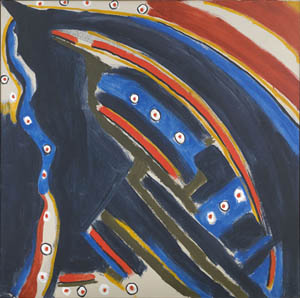Can you create a fictional story inspired by this image? In a far-off realm beyond the limits of space and time, there existed a cosmic entity known as the Astral Voyager. The Voyager was created from the very fabric of the universe, a swirling amalgam of deep blue voids and shimmering cosmic energy outlined by celestial forces. Each dot of red, yellow, and white represented a living star, housing entire worlds teeming with life and stories untold.

One day, the stars began to vanish one by one, consumed by an unknown darkness creeping through the universe. The Astral Voyager embarked on a journey across the cosmos, driven by an insatiable desire to uncover the mystery and restore light to the stars. Along its path, the Voyager encountered numerous galaxies and constellations, gathering knowledge and allies.

In a climactic battle, the Voyager confronted the source of the darkness, a forgotten deity exiled to the cosmic fringes. Through its unwavering resolve and the combined power of its celestial allies, the Voyager defeated the deity, reclaiming the stolen light and reigniting the stars. With the universe restored, the Astral Voyager continued its endless pilgrimage, forever a guardian of the cosmic harmony it had fought to preserve. 